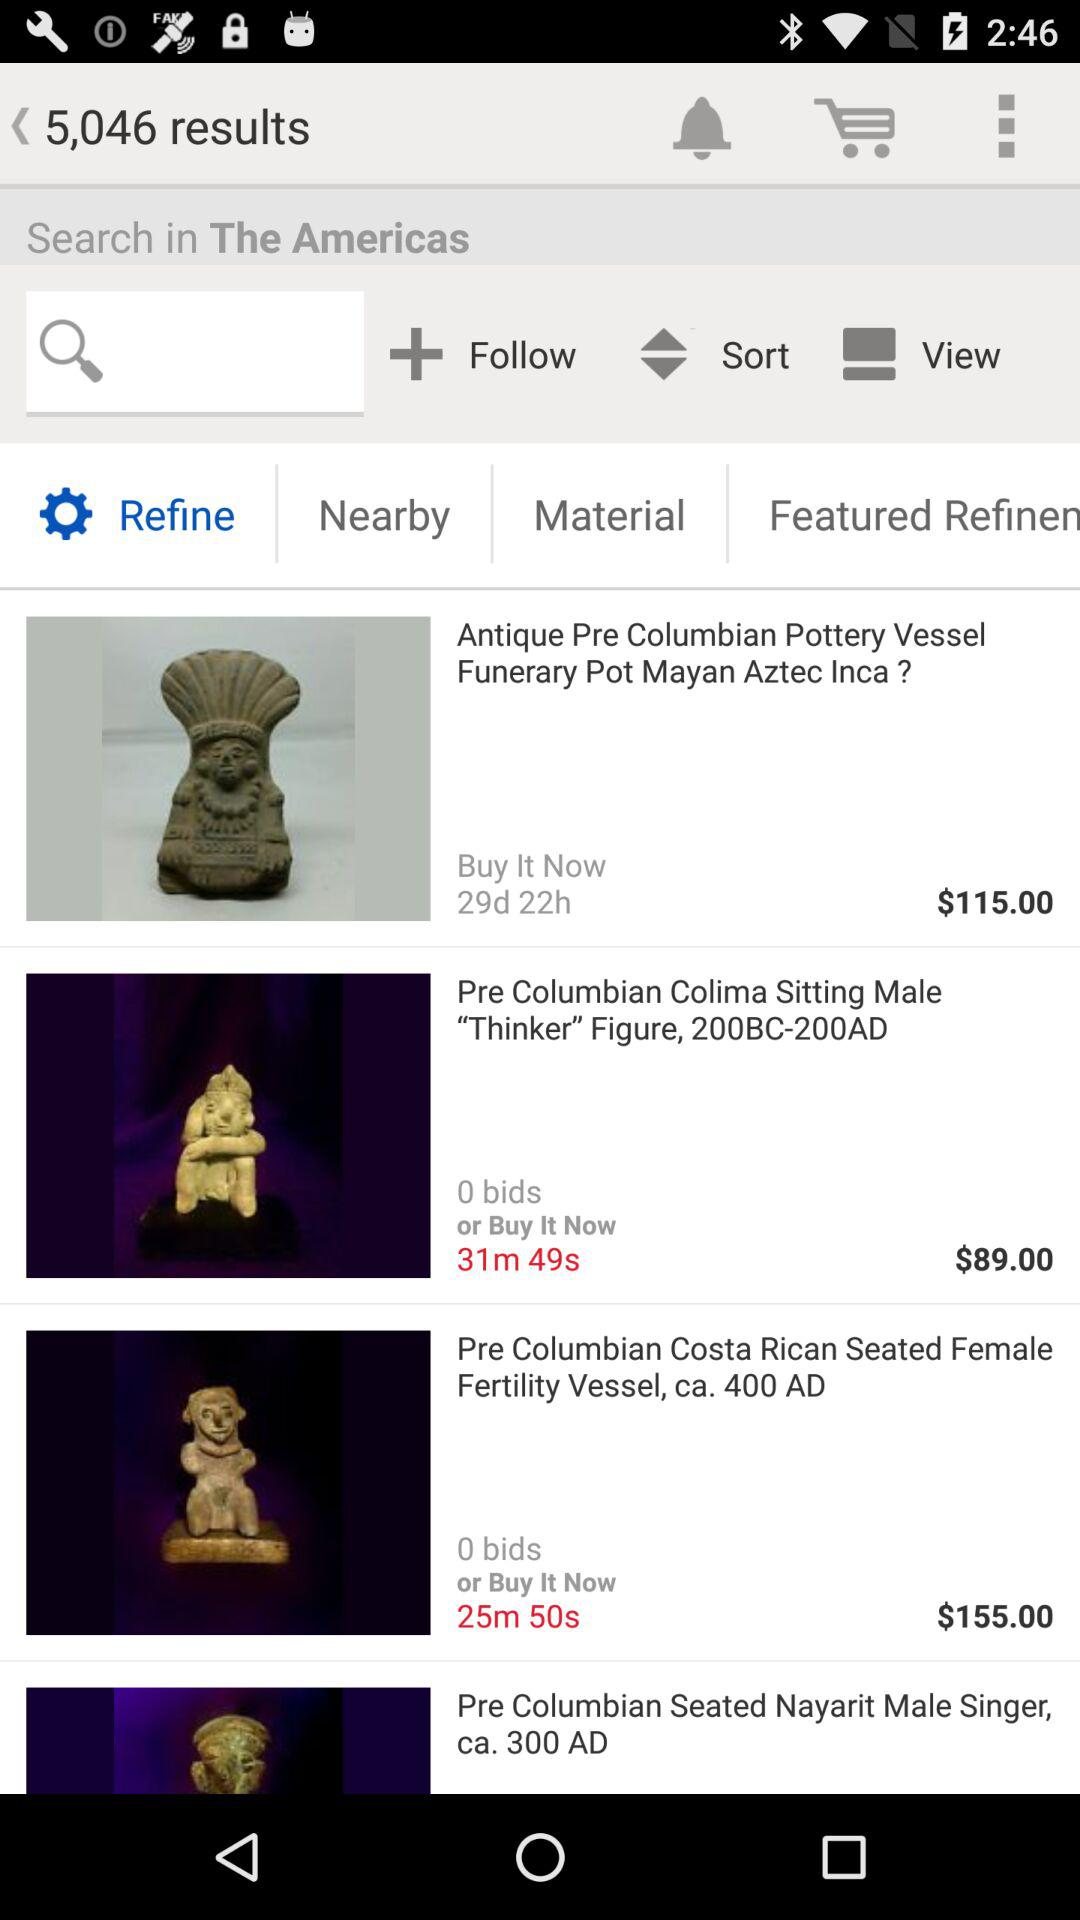What is the number of bids for "Pre Columbian Costa Rican Seated Female Fertility Vessel, ca. 400 AD"? The number of bids is 0. 